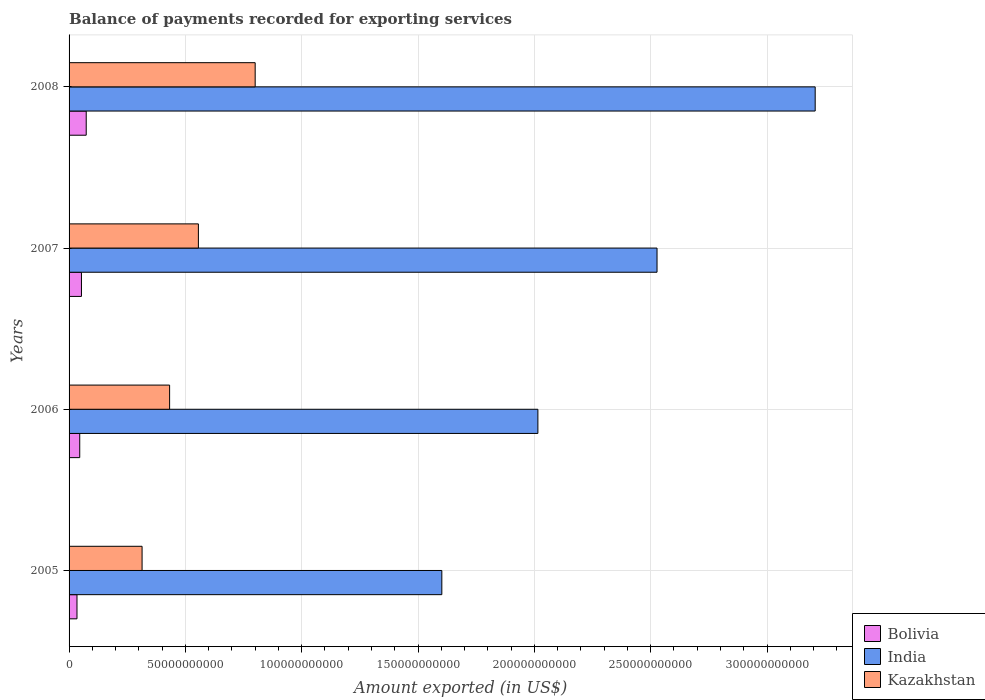How many different coloured bars are there?
Ensure brevity in your answer.  3. How many groups of bars are there?
Offer a terse response. 4. Are the number of bars per tick equal to the number of legend labels?
Make the answer very short. Yes. How many bars are there on the 4th tick from the bottom?
Your answer should be very brief. 3. What is the label of the 1st group of bars from the top?
Provide a succinct answer. 2008. In how many cases, is the number of bars for a given year not equal to the number of legend labels?
Your response must be concise. 0. What is the amount exported in Kazakhstan in 2008?
Offer a very short reply. 8.00e+1. Across all years, what is the maximum amount exported in India?
Ensure brevity in your answer.  3.21e+11. Across all years, what is the minimum amount exported in Kazakhstan?
Provide a succinct answer. 3.14e+1. In which year was the amount exported in Bolivia maximum?
Keep it short and to the point. 2008. What is the total amount exported in Bolivia in the graph?
Your answer should be compact. 2.07e+1. What is the difference between the amount exported in Kazakhstan in 2006 and that in 2007?
Offer a very short reply. -1.24e+1. What is the difference between the amount exported in India in 2008 and the amount exported in Bolivia in 2007?
Keep it short and to the point. 3.15e+11. What is the average amount exported in Bolivia per year?
Offer a very short reply. 5.17e+09. In the year 2006, what is the difference between the amount exported in India and amount exported in Kazakhstan?
Your answer should be compact. 1.58e+11. What is the ratio of the amount exported in India in 2006 to that in 2007?
Offer a terse response. 0.8. Is the amount exported in Bolivia in 2005 less than that in 2006?
Your response must be concise. Yes. Is the difference between the amount exported in India in 2006 and 2008 greater than the difference between the amount exported in Kazakhstan in 2006 and 2008?
Your response must be concise. No. What is the difference between the highest and the second highest amount exported in Bolivia?
Keep it short and to the point. 2.04e+09. What is the difference between the highest and the lowest amount exported in Kazakhstan?
Offer a very short reply. 4.86e+1. What does the 1st bar from the bottom in 2008 represents?
Make the answer very short. Bolivia. Is it the case that in every year, the sum of the amount exported in Bolivia and amount exported in Kazakhstan is greater than the amount exported in India?
Offer a very short reply. No. How many bars are there?
Provide a short and direct response. 12. How many years are there in the graph?
Give a very brief answer. 4. Does the graph contain grids?
Make the answer very short. Yes. How are the legend labels stacked?
Ensure brevity in your answer.  Vertical. What is the title of the graph?
Give a very brief answer. Balance of payments recorded for exporting services. What is the label or title of the X-axis?
Make the answer very short. Amount exported (in US$). What is the label or title of the Y-axis?
Ensure brevity in your answer.  Years. What is the Amount exported (in US$) of Bolivia in 2005?
Offer a very short reply. 3.40e+09. What is the Amount exported (in US$) of India in 2005?
Offer a very short reply. 1.60e+11. What is the Amount exported (in US$) of Kazakhstan in 2005?
Offer a very short reply. 3.14e+1. What is the Amount exported (in US$) of Bolivia in 2006?
Ensure brevity in your answer.  4.58e+09. What is the Amount exported (in US$) of India in 2006?
Offer a terse response. 2.02e+11. What is the Amount exported (in US$) of Kazakhstan in 2006?
Your response must be concise. 4.32e+1. What is the Amount exported (in US$) of Bolivia in 2007?
Offer a terse response. 5.32e+09. What is the Amount exported (in US$) of India in 2007?
Offer a very short reply. 2.53e+11. What is the Amount exported (in US$) in Kazakhstan in 2007?
Offer a very short reply. 5.56e+1. What is the Amount exported (in US$) of Bolivia in 2008?
Make the answer very short. 7.37e+09. What is the Amount exported (in US$) in India in 2008?
Give a very brief answer. 3.21e+11. What is the Amount exported (in US$) in Kazakhstan in 2008?
Give a very brief answer. 8.00e+1. Across all years, what is the maximum Amount exported (in US$) of Bolivia?
Your answer should be compact. 7.37e+09. Across all years, what is the maximum Amount exported (in US$) in India?
Give a very brief answer. 3.21e+11. Across all years, what is the maximum Amount exported (in US$) of Kazakhstan?
Offer a terse response. 8.00e+1. Across all years, what is the minimum Amount exported (in US$) of Bolivia?
Your answer should be very brief. 3.40e+09. Across all years, what is the minimum Amount exported (in US$) in India?
Offer a terse response. 1.60e+11. Across all years, what is the minimum Amount exported (in US$) in Kazakhstan?
Provide a short and direct response. 3.14e+1. What is the total Amount exported (in US$) in Bolivia in the graph?
Ensure brevity in your answer.  2.07e+1. What is the total Amount exported (in US$) in India in the graph?
Ensure brevity in your answer.  9.35e+11. What is the total Amount exported (in US$) of Kazakhstan in the graph?
Offer a very short reply. 2.10e+11. What is the difference between the Amount exported (in US$) in Bolivia in 2005 and that in 2006?
Make the answer very short. -1.18e+09. What is the difference between the Amount exported (in US$) of India in 2005 and that in 2006?
Ensure brevity in your answer.  -4.13e+1. What is the difference between the Amount exported (in US$) of Kazakhstan in 2005 and that in 2006?
Your answer should be compact. -1.18e+1. What is the difference between the Amount exported (in US$) of Bolivia in 2005 and that in 2007?
Provide a succinct answer. -1.92e+09. What is the difference between the Amount exported (in US$) of India in 2005 and that in 2007?
Provide a succinct answer. -9.25e+1. What is the difference between the Amount exported (in US$) of Kazakhstan in 2005 and that in 2007?
Offer a very short reply. -2.42e+1. What is the difference between the Amount exported (in US$) of Bolivia in 2005 and that in 2008?
Give a very brief answer. -3.97e+09. What is the difference between the Amount exported (in US$) in India in 2005 and that in 2008?
Ensure brevity in your answer.  -1.60e+11. What is the difference between the Amount exported (in US$) of Kazakhstan in 2005 and that in 2008?
Your response must be concise. -4.86e+1. What is the difference between the Amount exported (in US$) of Bolivia in 2006 and that in 2007?
Offer a very short reply. -7.40e+08. What is the difference between the Amount exported (in US$) of India in 2006 and that in 2007?
Make the answer very short. -5.12e+1. What is the difference between the Amount exported (in US$) in Kazakhstan in 2006 and that in 2007?
Offer a very short reply. -1.24e+1. What is the difference between the Amount exported (in US$) of Bolivia in 2006 and that in 2008?
Offer a very short reply. -2.78e+09. What is the difference between the Amount exported (in US$) in India in 2006 and that in 2008?
Provide a short and direct response. -1.19e+11. What is the difference between the Amount exported (in US$) in Kazakhstan in 2006 and that in 2008?
Make the answer very short. -3.68e+1. What is the difference between the Amount exported (in US$) of Bolivia in 2007 and that in 2008?
Provide a succinct answer. -2.04e+09. What is the difference between the Amount exported (in US$) of India in 2007 and that in 2008?
Offer a terse response. -6.80e+1. What is the difference between the Amount exported (in US$) in Kazakhstan in 2007 and that in 2008?
Make the answer very short. -2.44e+1. What is the difference between the Amount exported (in US$) in Bolivia in 2005 and the Amount exported (in US$) in India in 2006?
Give a very brief answer. -1.98e+11. What is the difference between the Amount exported (in US$) of Bolivia in 2005 and the Amount exported (in US$) of Kazakhstan in 2006?
Keep it short and to the point. -3.98e+1. What is the difference between the Amount exported (in US$) of India in 2005 and the Amount exported (in US$) of Kazakhstan in 2006?
Provide a short and direct response. 1.17e+11. What is the difference between the Amount exported (in US$) of Bolivia in 2005 and the Amount exported (in US$) of India in 2007?
Offer a very short reply. -2.49e+11. What is the difference between the Amount exported (in US$) of Bolivia in 2005 and the Amount exported (in US$) of Kazakhstan in 2007?
Your answer should be very brief. -5.22e+1. What is the difference between the Amount exported (in US$) of India in 2005 and the Amount exported (in US$) of Kazakhstan in 2007?
Your response must be concise. 1.05e+11. What is the difference between the Amount exported (in US$) in Bolivia in 2005 and the Amount exported (in US$) in India in 2008?
Offer a terse response. -3.17e+11. What is the difference between the Amount exported (in US$) in Bolivia in 2005 and the Amount exported (in US$) in Kazakhstan in 2008?
Offer a very short reply. -7.66e+1. What is the difference between the Amount exported (in US$) in India in 2005 and the Amount exported (in US$) in Kazakhstan in 2008?
Your response must be concise. 8.02e+1. What is the difference between the Amount exported (in US$) in Bolivia in 2006 and the Amount exported (in US$) in India in 2007?
Your answer should be very brief. -2.48e+11. What is the difference between the Amount exported (in US$) of Bolivia in 2006 and the Amount exported (in US$) of Kazakhstan in 2007?
Ensure brevity in your answer.  -5.10e+1. What is the difference between the Amount exported (in US$) in India in 2006 and the Amount exported (in US$) in Kazakhstan in 2007?
Give a very brief answer. 1.46e+11. What is the difference between the Amount exported (in US$) in Bolivia in 2006 and the Amount exported (in US$) in India in 2008?
Your answer should be very brief. -3.16e+11. What is the difference between the Amount exported (in US$) of Bolivia in 2006 and the Amount exported (in US$) of Kazakhstan in 2008?
Your response must be concise. -7.54e+1. What is the difference between the Amount exported (in US$) in India in 2006 and the Amount exported (in US$) in Kazakhstan in 2008?
Your response must be concise. 1.22e+11. What is the difference between the Amount exported (in US$) of Bolivia in 2007 and the Amount exported (in US$) of India in 2008?
Provide a succinct answer. -3.15e+11. What is the difference between the Amount exported (in US$) in Bolivia in 2007 and the Amount exported (in US$) in Kazakhstan in 2008?
Ensure brevity in your answer.  -7.47e+1. What is the difference between the Amount exported (in US$) in India in 2007 and the Amount exported (in US$) in Kazakhstan in 2008?
Provide a short and direct response. 1.73e+11. What is the average Amount exported (in US$) in Bolivia per year?
Provide a succinct answer. 5.17e+09. What is the average Amount exported (in US$) in India per year?
Provide a short and direct response. 2.34e+11. What is the average Amount exported (in US$) of Kazakhstan per year?
Ensure brevity in your answer.  5.25e+1. In the year 2005, what is the difference between the Amount exported (in US$) of Bolivia and Amount exported (in US$) of India?
Provide a succinct answer. -1.57e+11. In the year 2005, what is the difference between the Amount exported (in US$) in Bolivia and Amount exported (in US$) in Kazakhstan?
Give a very brief answer. -2.80e+1. In the year 2005, what is the difference between the Amount exported (in US$) in India and Amount exported (in US$) in Kazakhstan?
Provide a short and direct response. 1.29e+11. In the year 2006, what is the difference between the Amount exported (in US$) of Bolivia and Amount exported (in US$) of India?
Give a very brief answer. -1.97e+11. In the year 2006, what is the difference between the Amount exported (in US$) of Bolivia and Amount exported (in US$) of Kazakhstan?
Give a very brief answer. -3.86e+1. In the year 2006, what is the difference between the Amount exported (in US$) in India and Amount exported (in US$) in Kazakhstan?
Keep it short and to the point. 1.58e+11. In the year 2007, what is the difference between the Amount exported (in US$) in Bolivia and Amount exported (in US$) in India?
Offer a very short reply. -2.47e+11. In the year 2007, what is the difference between the Amount exported (in US$) in Bolivia and Amount exported (in US$) in Kazakhstan?
Offer a terse response. -5.03e+1. In the year 2007, what is the difference between the Amount exported (in US$) in India and Amount exported (in US$) in Kazakhstan?
Your response must be concise. 1.97e+11. In the year 2008, what is the difference between the Amount exported (in US$) of Bolivia and Amount exported (in US$) of India?
Make the answer very short. -3.13e+11. In the year 2008, what is the difference between the Amount exported (in US$) in Bolivia and Amount exported (in US$) in Kazakhstan?
Keep it short and to the point. -7.26e+1. In the year 2008, what is the difference between the Amount exported (in US$) of India and Amount exported (in US$) of Kazakhstan?
Give a very brief answer. 2.41e+11. What is the ratio of the Amount exported (in US$) in Bolivia in 2005 to that in 2006?
Offer a very short reply. 0.74. What is the ratio of the Amount exported (in US$) in India in 2005 to that in 2006?
Provide a succinct answer. 0.8. What is the ratio of the Amount exported (in US$) in Kazakhstan in 2005 to that in 2006?
Your answer should be compact. 0.73. What is the ratio of the Amount exported (in US$) in Bolivia in 2005 to that in 2007?
Offer a very short reply. 0.64. What is the ratio of the Amount exported (in US$) of India in 2005 to that in 2007?
Your answer should be compact. 0.63. What is the ratio of the Amount exported (in US$) of Kazakhstan in 2005 to that in 2007?
Provide a short and direct response. 0.56. What is the ratio of the Amount exported (in US$) in Bolivia in 2005 to that in 2008?
Keep it short and to the point. 0.46. What is the ratio of the Amount exported (in US$) of India in 2005 to that in 2008?
Keep it short and to the point. 0.5. What is the ratio of the Amount exported (in US$) of Kazakhstan in 2005 to that in 2008?
Ensure brevity in your answer.  0.39. What is the ratio of the Amount exported (in US$) of Bolivia in 2006 to that in 2007?
Your answer should be very brief. 0.86. What is the ratio of the Amount exported (in US$) of India in 2006 to that in 2007?
Your answer should be compact. 0.8. What is the ratio of the Amount exported (in US$) of Kazakhstan in 2006 to that in 2007?
Provide a short and direct response. 0.78. What is the ratio of the Amount exported (in US$) in Bolivia in 2006 to that in 2008?
Your response must be concise. 0.62. What is the ratio of the Amount exported (in US$) of India in 2006 to that in 2008?
Ensure brevity in your answer.  0.63. What is the ratio of the Amount exported (in US$) in Kazakhstan in 2006 to that in 2008?
Your response must be concise. 0.54. What is the ratio of the Amount exported (in US$) in Bolivia in 2007 to that in 2008?
Offer a terse response. 0.72. What is the ratio of the Amount exported (in US$) in India in 2007 to that in 2008?
Ensure brevity in your answer.  0.79. What is the ratio of the Amount exported (in US$) in Kazakhstan in 2007 to that in 2008?
Keep it short and to the point. 0.69. What is the difference between the highest and the second highest Amount exported (in US$) of Bolivia?
Give a very brief answer. 2.04e+09. What is the difference between the highest and the second highest Amount exported (in US$) of India?
Offer a terse response. 6.80e+1. What is the difference between the highest and the second highest Amount exported (in US$) of Kazakhstan?
Provide a short and direct response. 2.44e+1. What is the difference between the highest and the lowest Amount exported (in US$) of Bolivia?
Ensure brevity in your answer.  3.97e+09. What is the difference between the highest and the lowest Amount exported (in US$) of India?
Your answer should be compact. 1.60e+11. What is the difference between the highest and the lowest Amount exported (in US$) in Kazakhstan?
Give a very brief answer. 4.86e+1. 